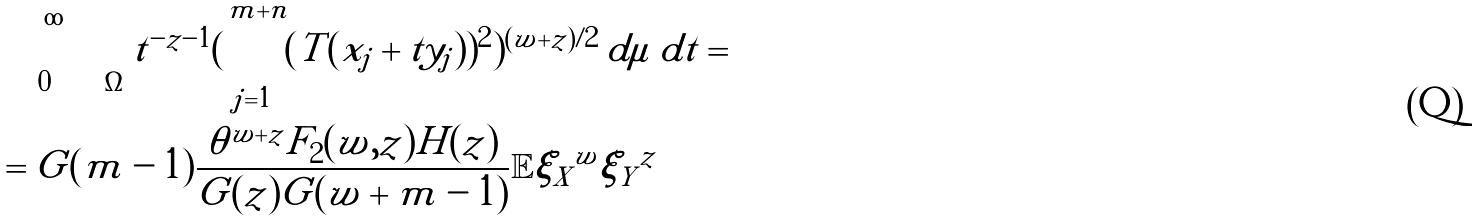<formula> <loc_0><loc_0><loc_500><loc_500>& \int _ { 0 } ^ { \infty } \int _ { \Omega } t ^ { - z - 1 } ( \sum _ { j = 1 } ^ { m + n } ( T ( x _ { j } + t y _ { j } ) ) ^ { 2 } ) ^ { ( w + z ) / 2 } \, d \mu \, d t = \\ & = G ( m - 1 ) \frac { \theta ^ { w + z } F _ { 2 } ( w , z ) H ( z ) } { G ( z ) G ( w + m - 1 ) } \mathbb { E } \| \xi _ { X } \| ^ { w } \| \xi _ { Y } \| ^ { z }</formula> 